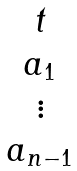Convert formula to latex. <formula><loc_0><loc_0><loc_500><loc_500>\begin{matrix} t \\ a _ { 1 } \\ \vdots \\ a _ { n - 1 } \end{matrix}</formula> 